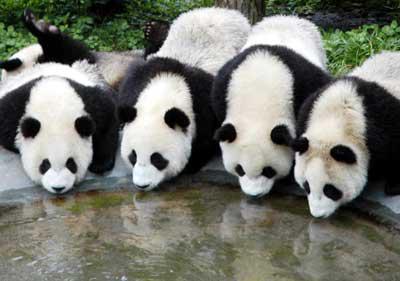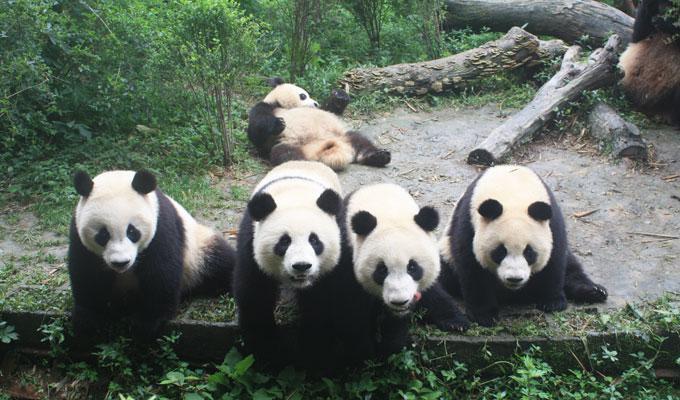The first image is the image on the left, the second image is the image on the right. Given the left and right images, does the statement "The image to the left features exactly four pandas." hold true? Answer yes or no. Yes. The first image is the image on the left, the second image is the image on the right. Evaluate the accuracy of this statement regarding the images: "An image with exactly four pandas includes one with its front paws outspread, reaching toward the panda on either side of it.". Is it true? Answer yes or no. No. 